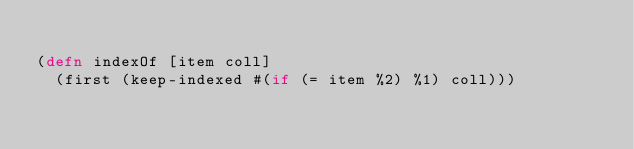Convert code to text. <code><loc_0><loc_0><loc_500><loc_500><_Clojure_>
(defn indexOf [item coll]
  (first (keep-indexed #(if (= item %2) %1) coll)))
</code> 